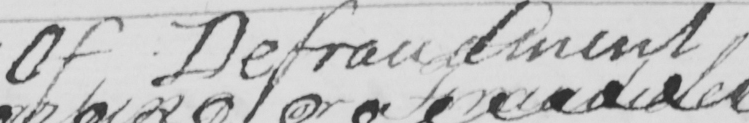Please provide the text content of this handwritten line. Of Defraudment 